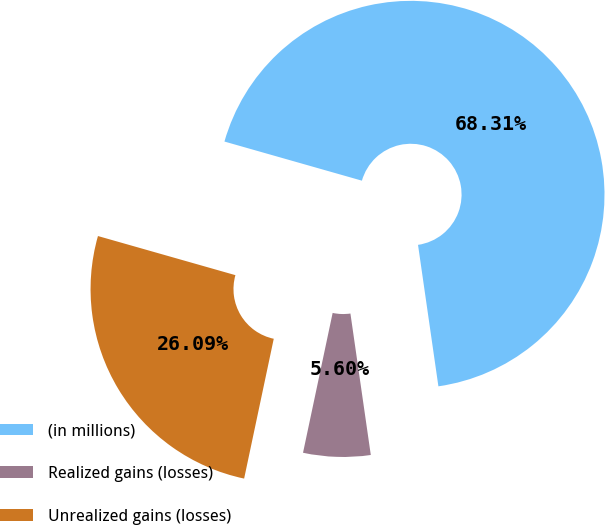Convert chart to OTSL. <chart><loc_0><loc_0><loc_500><loc_500><pie_chart><fcel>(in millions)<fcel>Realized gains (losses)<fcel>Unrealized gains (losses)<nl><fcel>68.31%<fcel>5.6%<fcel>26.09%<nl></chart> 